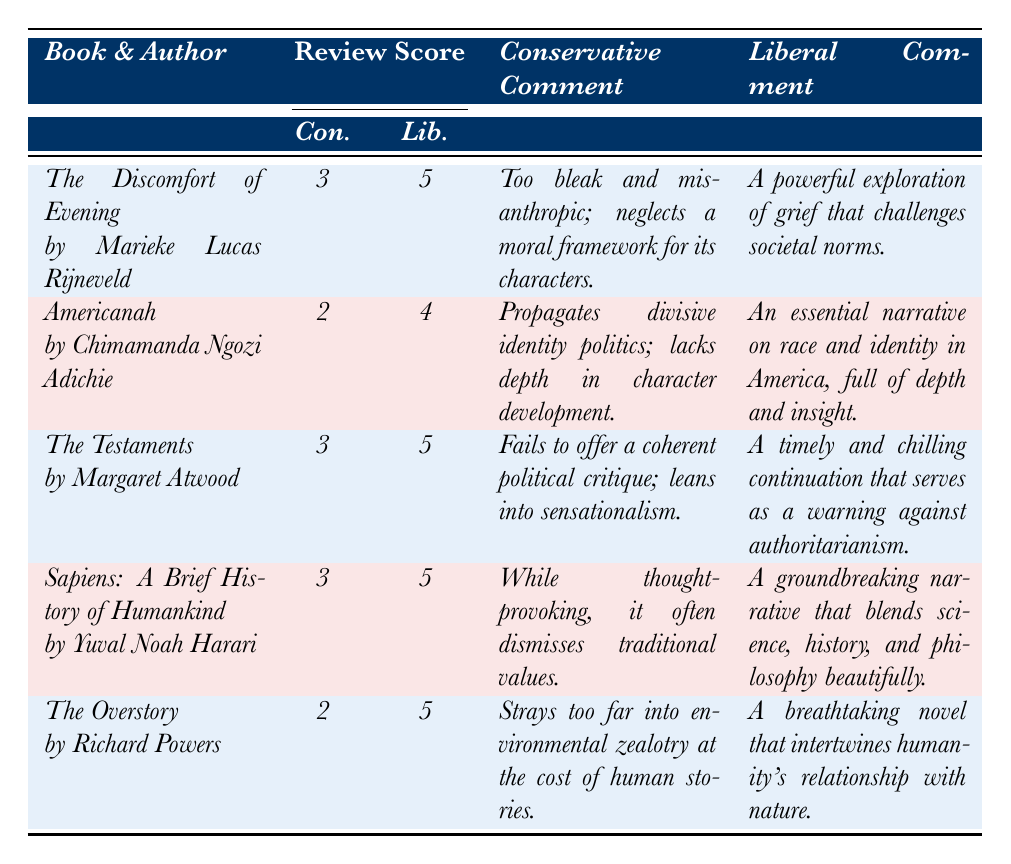What is the highest score given by a conservative publication? The table shows review scores from conservative publications. The highest score is 3, which appears in three instances for "The Discomfort of Evening," "The Testaments," and "Sapiens."
Answer: 3 Which book received the lowest score from a conservative publication? The table shows that "Americanah" and "The Overstory" both received the lowest score of 2 from conservative publications.
Answer: Americanah and The Overstory What is the average score given by liberal publications? The scores given by liberal publications are 5, 4, 5, 5, and 5. Adding them up gives 24, and dividing by 5 (the number of books) results in an average of 4.8.
Answer: 4.8 Is there a book that received the same score from both conservative and liberal reviews? By examining the scores, "The Discomfort of Evening" received a score of 3 from conservatives and 5 from liberals. All other books also received different scores. Hence, there isn’t a book with the same score from both sides.
Answer: No What is the difference in scores for "The Testaments" between the conservative and liberal reviews? "The Testaments" received a score of 3 from conservatives and a score of 5 from liberals. The difference is calculated as 5 - 3 = 2.
Answer: 2 Which book received the highest score from a liberal publication? The highest score from liberal publications is 5, awarded to "The Discomfort of Evening," "The Testaments," "Sapiens," and "The Overstory."
Answer: The Discomfort of Evening, The Testaments, Sapiens, The Overstory What percentage of the books scored 5 by liberal publications? Four out of five books scored 5 by liberal publications, which means (4/5) * 100% = 80%.
Answer: 80% Which conservative review mentioned a concern about identity politics? The table shows that "Americanah" received a conservative review that stated it propagates divisive identity politics.
Answer: Americanah How many books received a conservative score of 3? The table shows that "The Discomfort of Evening," "The Testaments," and "Sapiens" each received a score of 3 from conservative publications, giving us a total of 3 books.
Answer: 3 